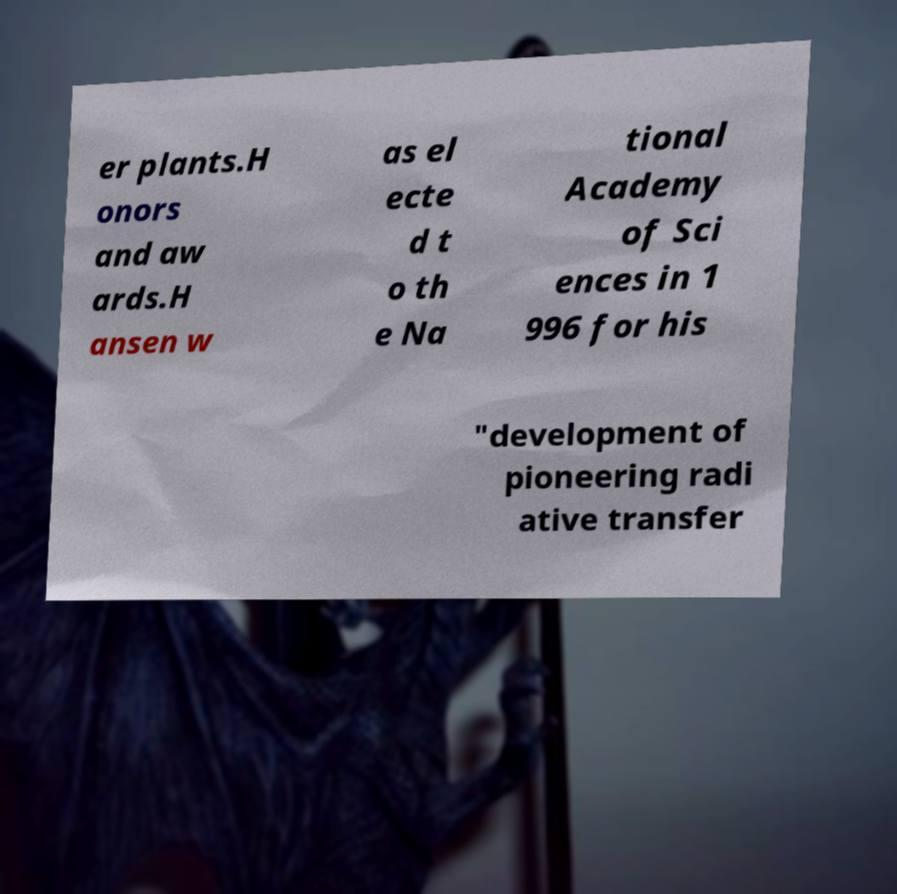Can you read and provide the text displayed in the image?This photo seems to have some interesting text. Can you extract and type it out for me? er plants.H onors and aw ards.H ansen w as el ecte d t o th e Na tional Academy of Sci ences in 1 996 for his "development of pioneering radi ative transfer 